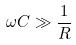Convert formula to latex. <formula><loc_0><loc_0><loc_500><loc_500>\omega C \gg \frac { 1 } { R }</formula> 